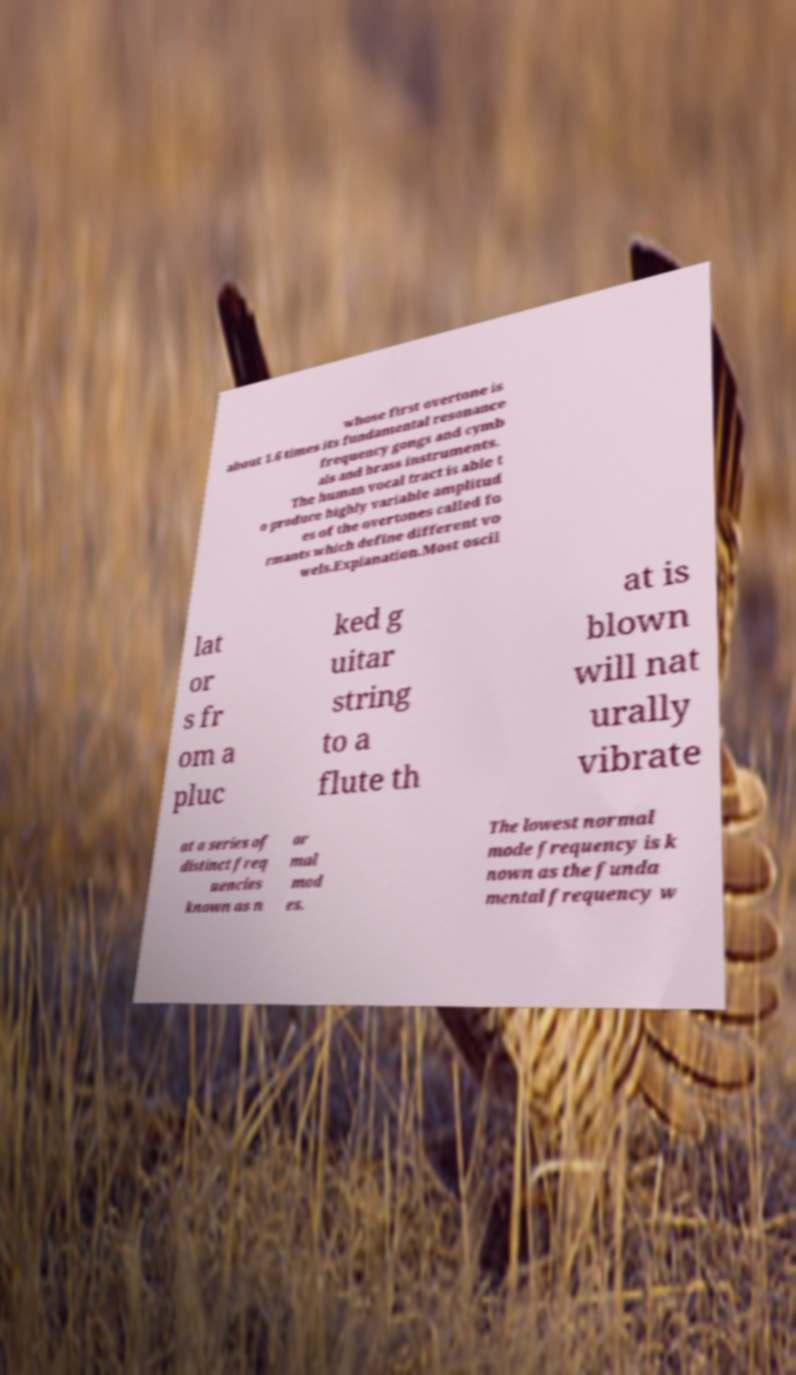Could you extract and type out the text from this image? whose first overtone is about 1.6 times its fundamental resonance frequency gongs and cymb als and brass instruments. The human vocal tract is able t o produce highly variable amplitud es of the overtones called fo rmants which define different vo wels.Explanation.Most oscil lat or s fr om a pluc ked g uitar string to a flute th at is blown will nat urally vibrate at a series of distinct freq uencies known as n or mal mod es. The lowest normal mode frequency is k nown as the funda mental frequency w 